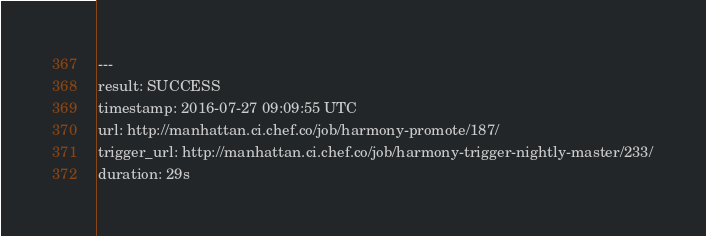<code> <loc_0><loc_0><loc_500><loc_500><_YAML_>---
result: SUCCESS
timestamp: 2016-07-27 09:09:55 UTC
url: http://manhattan.ci.chef.co/job/harmony-promote/187/
trigger_url: http://manhattan.ci.chef.co/job/harmony-trigger-nightly-master/233/
duration: 29s
</code> 